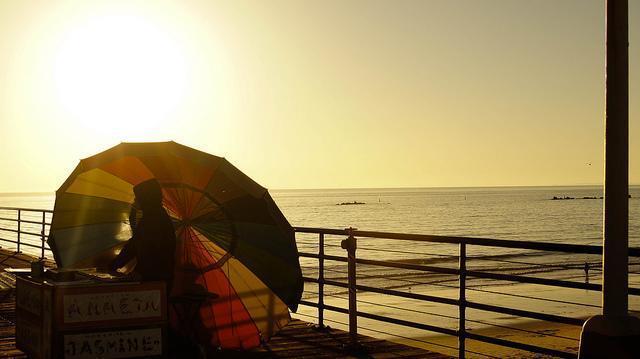How many rolls of toilet paper are in the picture?
Give a very brief answer. 0. 